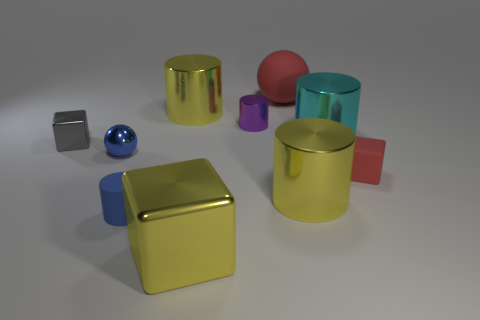How many yellow cylinders must be subtracted to get 1 yellow cylinders? 1 Subtract all metal blocks. How many blocks are left? 1 Subtract all red spheres. How many yellow cylinders are left? 2 Subtract all red cubes. How many cubes are left? 2 Subtract all spheres. How many objects are left? 8 Subtract 2 cylinders. How many cylinders are left? 3 Subtract all blue spheres. Subtract all blue cylinders. How many spheres are left? 1 Subtract all matte objects. Subtract all tiny gray shiny things. How many objects are left? 6 Add 8 tiny rubber blocks. How many tiny rubber blocks are left? 9 Add 7 big blue cubes. How many big blue cubes exist? 7 